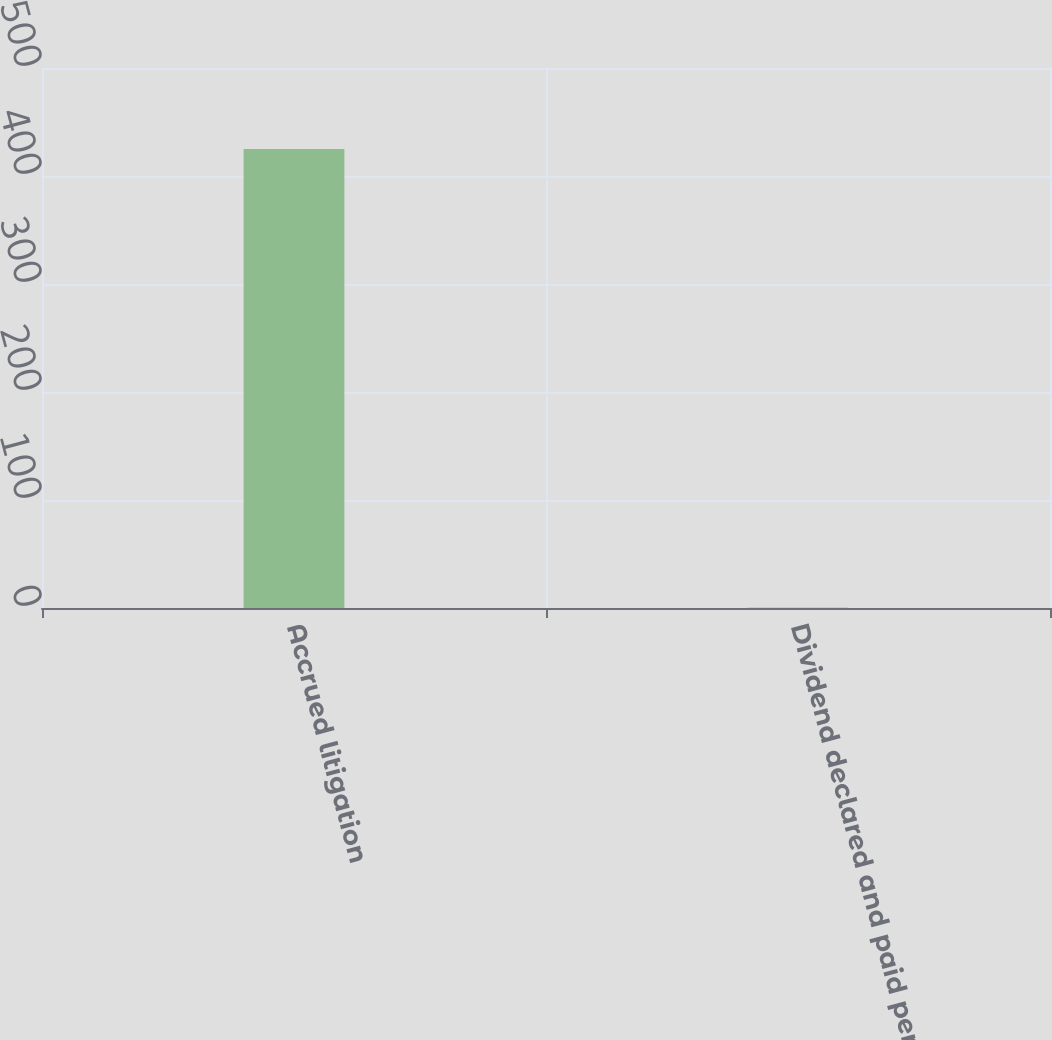<chart> <loc_0><loc_0><loc_500><loc_500><bar_chart><fcel>Accrued litigation<fcel>Dividend declared and paid per<nl><fcel>425<fcel>0.15<nl></chart> 